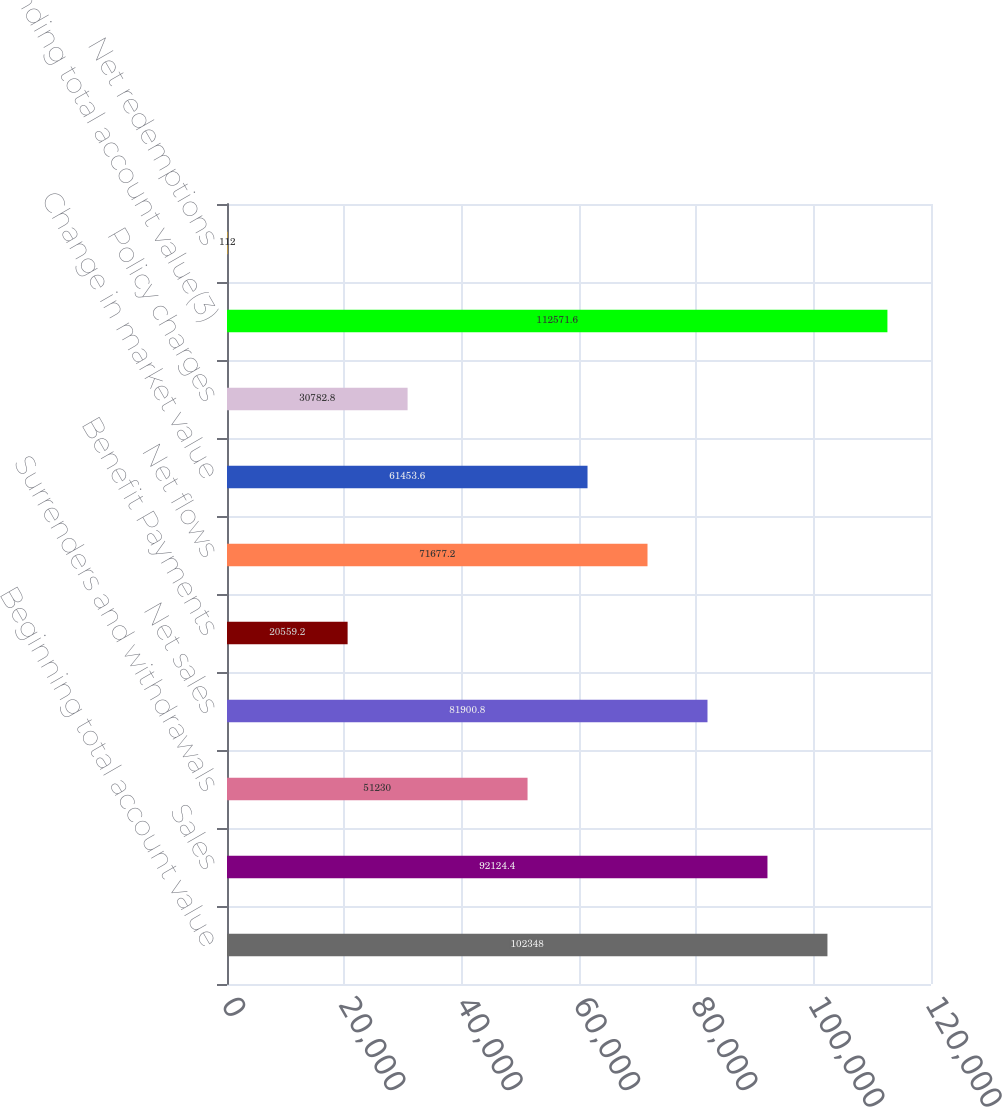Convert chart. <chart><loc_0><loc_0><loc_500><loc_500><bar_chart><fcel>Beginning total account value<fcel>Sales<fcel>Surrenders and withdrawals<fcel>Net sales<fcel>Benefit Payments<fcel>Net flows<fcel>Change in market value<fcel>Policy charges<fcel>Ending total account value(3)<fcel>Net redemptions<nl><fcel>102348<fcel>92124.4<fcel>51230<fcel>81900.8<fcel>20559.2<fcel>71677.2<fcel>61453.6<fcel>30782.8<fcel>112572<fcel>112<nl></chart> 